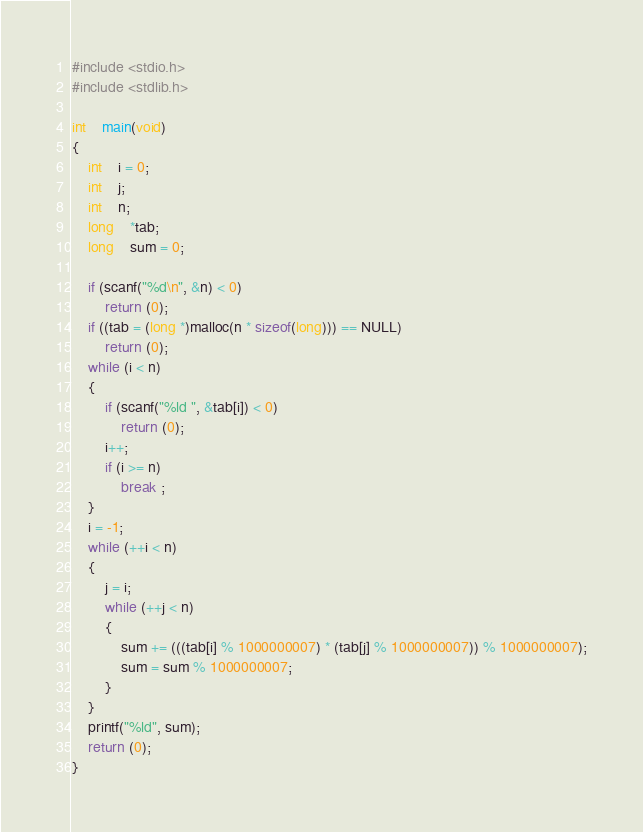Convert code to text. <code><loc_0><loc_0><loc_500><loc_500><_C_>#include <stdio.h>
#include <stdlib.h>
	
int	main(void)
{
	int	i = 0;
	int	j;
	int	n;
	long	*tab;
	long	sum = 0;
	
	if (scanf("%d\n", &n) < 0)
		return (0);
	if ((tab = (long *)malloc(n * sizeof(long))) == NULL)
		return (0);
	while (i < n)
	{
		if (scanf("%ld ", &tab[i]) < 0)
			return (0);
		i++;
		if (i >= n)
			break ;
	}
	i = -1;
	while (++i < n)
	{
		j = i;
		while (++j < n)
		{
			sum += (((tab[i] % 1000000007) * (tab[j] % 1000000007)) % 1000000007);
			sum = sum % 1000000007;
		}
	}
	printf("%ld", sum);
	return (0);
}</code> 